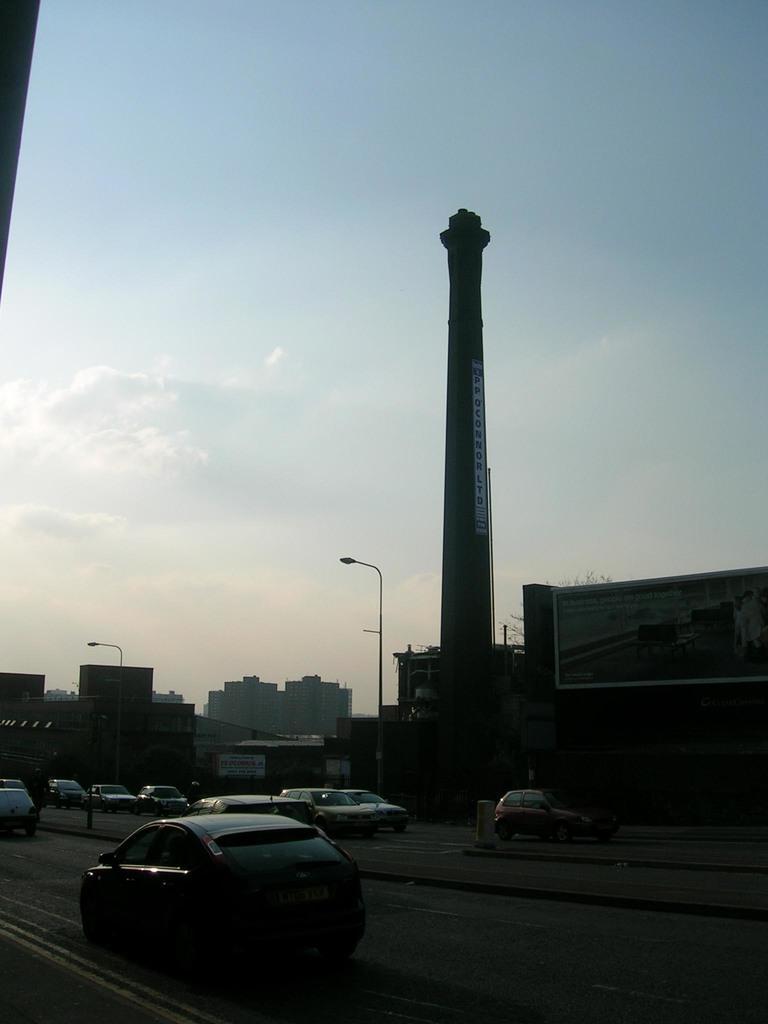Describe this image in one or two sentences. In this picture we can see cars on the road, buildings, poles and in the background we can see the sky with clouds. 